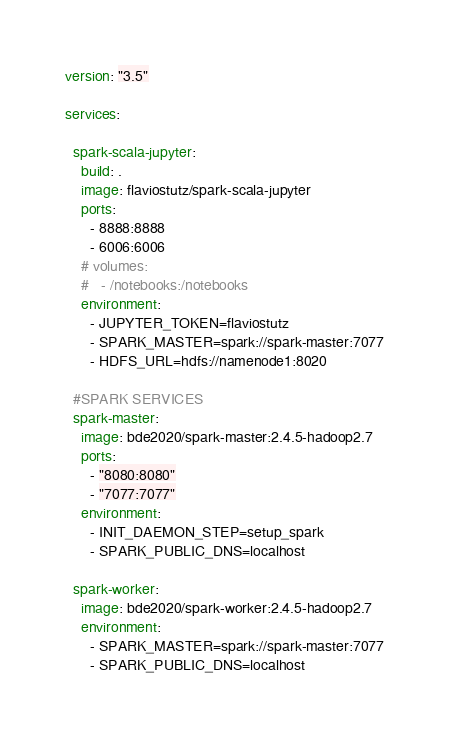<code> <loc_0><loc_0><loc_500><loc_500><_YAML_>version: "3.5"

services:

  spark-scala-jupyter:
    build: .
    image: flaviostutz/spark-scala-jupyter
    ports:
      - 8888:8888
      - 6006:6006
    # volumes:
    #   - /notebooks:/notebooks
    environment:
      - JUPYTER_TOKEN=flaviostutz
      - SPARK_MASTER=spark://spark-master:7077
      - HDFS_URL=hdfs://namenode1:8020

  #SPARK SERVICES
  spark-master:
    image: bde2020/spark-master:2.4.5-hadoop2.7
    ports:
      - "8080:8080"
      - "7077:7077"
    environment:
      - INIT_DAEMON_STEP=setup_spark
      - SPARK_PUBLIC_DNS=localhost

  spark-worker:
    image: bde2020/spark-worker:2.4.5-hadoop2.7
    environment:
      - SPARK_MASTER=spark://spark-master:7077
      - SPARK_PUBLIC_DNS=localhost
</code> 